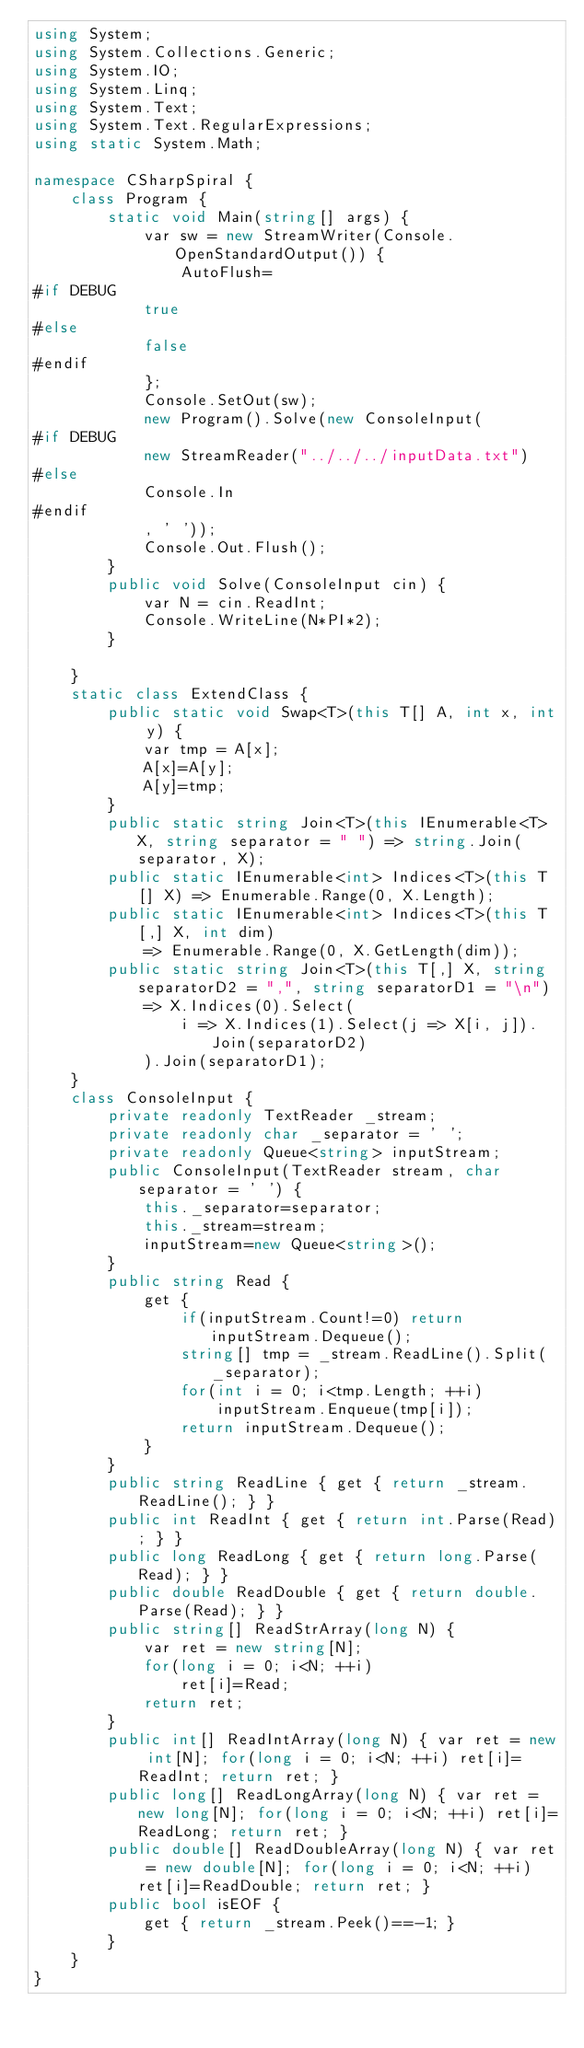Convert code to text. <code><loc_0><loc_0><loc_500><loc_500><_C#_>using System;
using System.Collections.Generic;
using System.IO;
using System.Linq;
using System.Text;
using System.Text.RegularExpressions;
using static System.Math;

namespace CSharpSpiral {
	class Program {
		static void Main(string[] args) {
			var sw = new StreamWriter(Console.OpenStandardOutput()) {
				AutoFlush=
#if DEBUG
			true
#else
			false
#endif
			};
			Console.SetOut(sw);
			new Program().Solve(new ConsoleInput(
#if DEBUG
			new StreamReader("../../../inputData.txt")
#else
			Console.In
#endif
			, ' '));
			Console.Out.Flush();
		}
		public void Solve(ConsoleInput cin) {
			var N = cin.ReadInt;
			Console.WriteLine(N*PI*2);
		}

	}
	static class ExtendClass {
		public static void Swap<T>(this T[] A, int x, int y) {
			var tmp = A[x];
			A[x]=A[y];
			A[y]=tmp;
		}
		public static string Join<T>(this IEnumerable<T> X, string separator = " ") => string.Join(separator, X);
		public static IEnumerable<int> Indices<T>(this T[] X) => Enumerable.Range(0, X.Length);
		public static IEnumerable<int> Indices<T>(this T[,] X, int dim)
			=> Enumerable.Range(0, X.GetLength(dim));
		public static string Join<T>(this T[,] X, string separatorD2 = ",", string separatorD1 = "\n")
			=> X.Indices(0).Select(
				i => X.Indices(1).Select(j => X[i, j]).Join(separatorD2)
			).Join(separatorD1);
	}
	class ConsoleInput {
		private readonly TextReader _stream;
		private readonly char _separator = ' ';
		private readonly Queue<string> inputStream;
		public ConsoleInput(TextReader stream, char separator = ' ') {
			this._separator=separator;
			this._stream=stream;
			inputStream=new Queue<string>();
		}
		public string Read {
			get {
				if(inputStream.Count!=0) return inputStream.Dequeue();
				string[] tmp = _stream.ReadLine().Split(_separator);
				for(int i = 0; i<tmp.Length; ++i)
					inputStream.Enqueue(tmp[i]);
				return inputStream.Dequeue();
			}
		}
		public string ReadLine { get { return _stream.ReadLine(); } }
		public int ReadInt { get { return int.Parse(Read); } }
		public long ReadLong { get { return long.Parse(Read); } }
		public double ReadDouble { get { return double.Parse(Read); } }
		public string[] ReadStrArray(long N) {
			var ret = new string[N];
			for(long i = 0; i<N; ++i)
				ret[i]=Read;
			return ret;
		}
		public int[] ReadIntArray(long N) { var ret = new int[N]; for(long i = 0; i<N; ++i) ret[i]=ReadInt; return ret; }
		public long[] ReadLongArray(long N) { var ret = new long[N]; for(long i = 0; i<N; ++i) ret[i]=ReadLong; return ret; }
		public double[] ReadDoubleArray(long N) { var ret = new double[N]; for(long i = 0; i<N; ++i) ret[i]=ReadDouble; return ret; }
		public bool isEOF {
			get { return _stream.Peek()==-1; }
		}
	}
}
</code> 